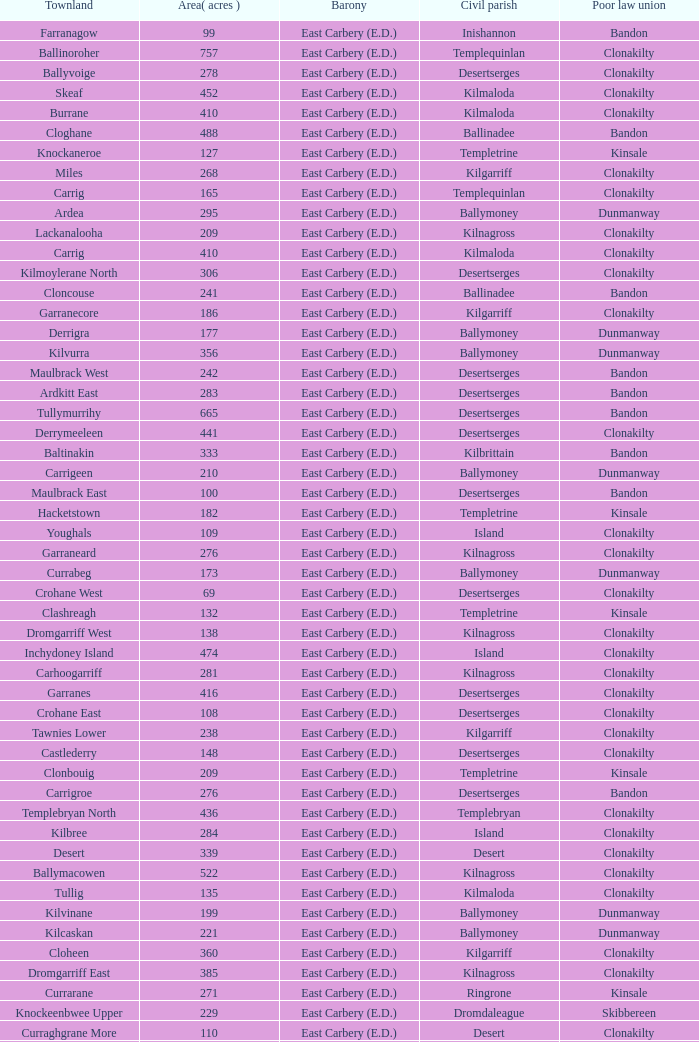What is the poor law union of the Ardacrow townland? Bandon. 